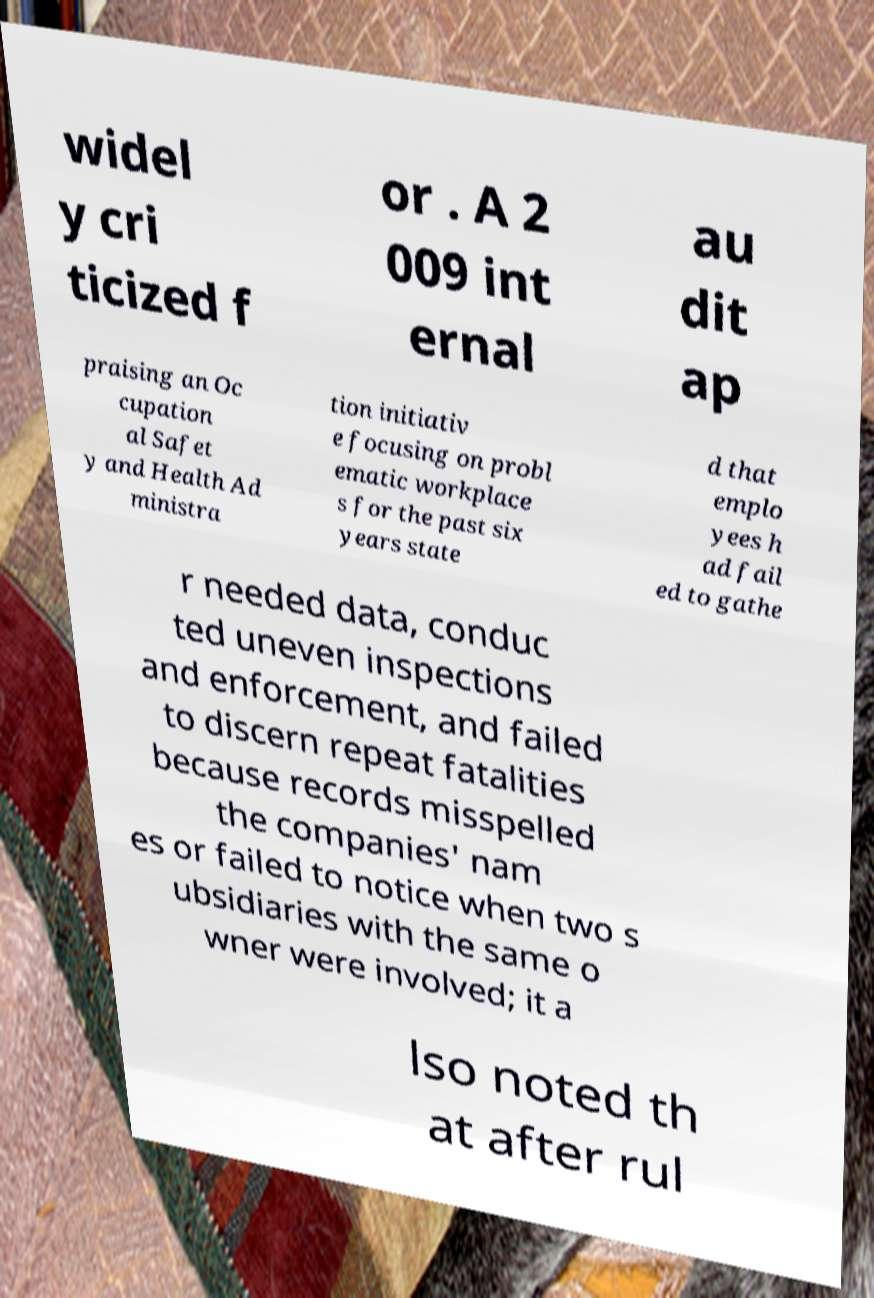Could you assist in decoding the text presented in this image and type it out clearly? widel y cri ticized f or . A 2 009 int ernal au dit ap praising an Oc cupation al Safet y and Health Ad ministra tion initiativ e focusing on probl ematic workplace s for the past six years state d that emplo yees h ad fail ed to gathe r needed data, conduc ted uneven inspections and enforcement, and failed to discern repeat fatalities because records misspelled the companies' nam es or failed to notice when two s ubsidiaries with the same o wner were involved; it a lso noted th at after rul 